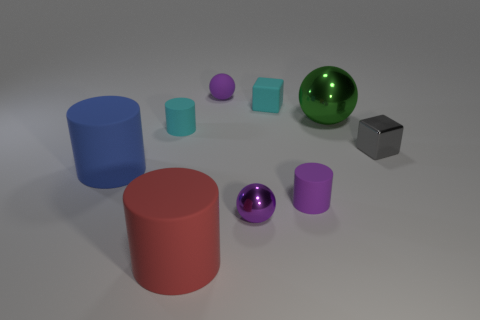Subtract all gray cylinders. How many purple spheres are left? 2 Subtract 2 cylinders. How many cylinders are left? 2 Add 1 gray cubes. How many objects exist? 10 Subtract all rubber spheres. How many spheres are left? 2 Subtract all purple cylinders. How many cylinders are left? 3 Subtract all cubes. How many objects are left? 7 Subtract all green cylinders. Subtract all yellow blocks. How many cylinders are left? 4 Subtract all cyan matte cylinders. Subtract all tiny purple objects. How many objects are left? 5 Add 8 cyan matte objects. How many cyan matte objects are left? 10 Add 2 tiny matte spheres. How many tiny matte spheres exist? 3 